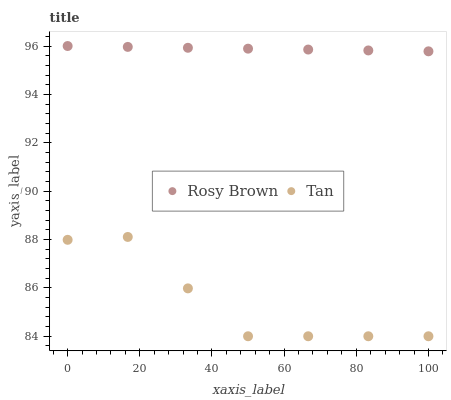Does Tan have the minimum area under the curve?
Answer yes or no. Yes. Does Rosy Brown have the maximum area under the curve?
Answer yes or no. Yes. Does Rosy Brown have the minimum area under the curve?
Answer yes or no. No. Is Rosy Brown the smoothest?
Answer yes or no. Yes. Is Tan the roughest?
Answer yes or no. Yes. Is Rosy Brown the roughest?
Answer yes or no. No. Does Tan have the lowest value?
Answer yes or no. Yes. Does Rosy Brown have the lowest value?
Answer yes or no. No. Does Rosy Brown have the highest value?
Answer yes or no. Yes. Is Tan less than Rosy Brown?
Answer yes or no. Yes. Is Rosy Brown greater than Tan?
Answer yes or no. Yes. Does Tan intersect Rosy Brown?
Answer yes or no. No. 